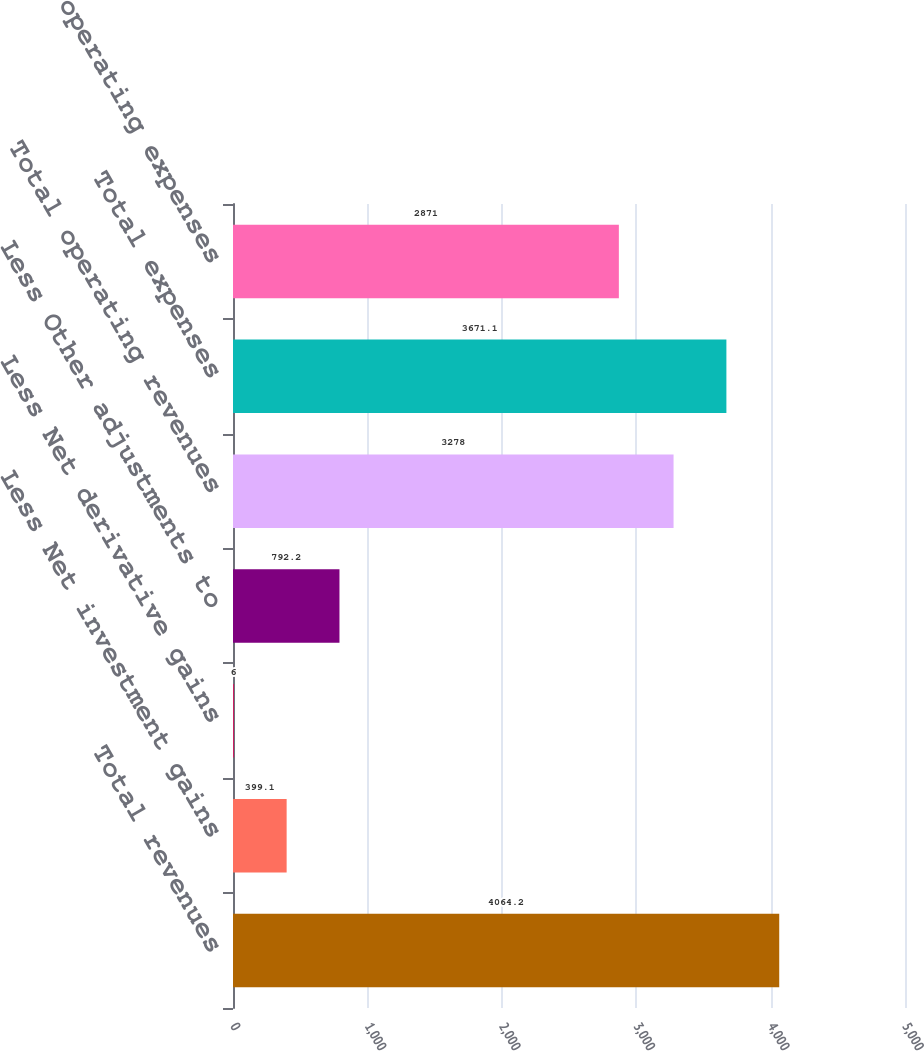<chart> <loc_0><loc_0><loc_500><loc_500><bar_chart><fcel>Total revenues<fcel>Less Net investment gains<fcel>Less Net derivative gains<fcel>Less Other adjustments to<fcel>Total operating revenues<fcel>Total expenses<fcel>Total operating expenses<nl><fcel>4064.2<fcel>399.1<fcel>6<fcel>792.2<fcel>3278<fcel>3671.1<fcel>2871<nl></chart> 